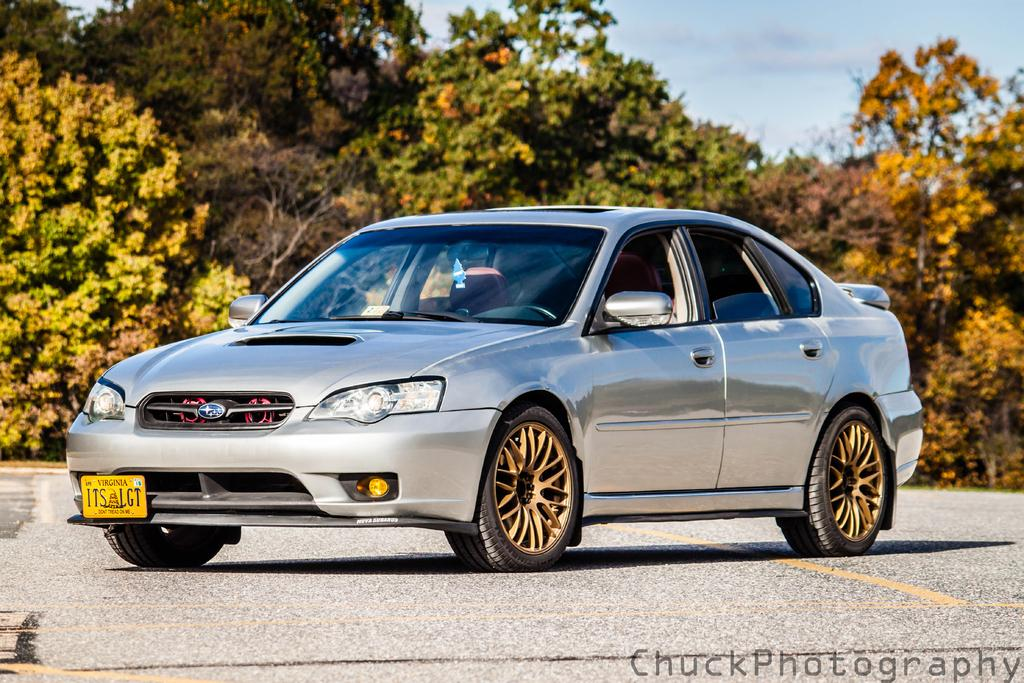What is the main subject of the image? There is a vehicle on the road in the image. What can be seen in the background of the image? The sky is visible in the background of the image. Are there any natural elements present in the image? Yes, there are trees visible in the image. What language is the vehicle speaking in the image? Vehicles do not speak languages; they are inanimate objects. 